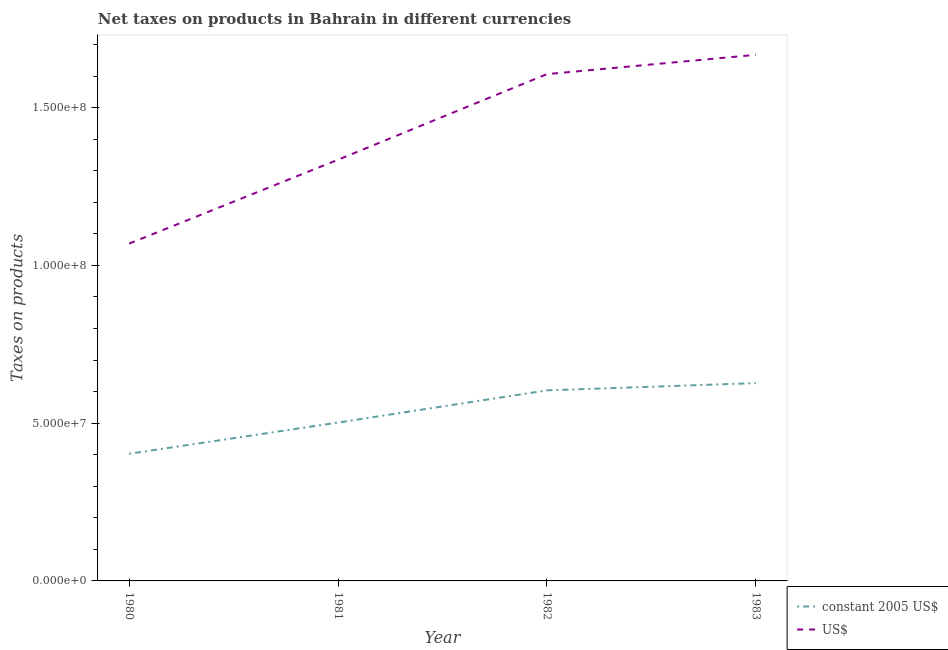How many different coloured lines are there?
Provide a succinct answer. 2. What is the net taxes in us$ in 1981?
Provide a short and direct response. 1.34e+08. Across all years, what is the maximum net taxes in us$?
Your answer should be compact. 1.67e+08. Across all years, what is the minimum net taxes in us$?
Offer a terse response. 1.07e+08. In which year was the net taxes in constant 2005 us$ maximum?
Keep it short and to the point. 1983. What is the total net taxes in us$ in the graph?
Make the answer very short. 5.68e+08. What is the difference between the net taxes in us$ in 1980 and that in 1981?
Keep it short and to the point. -2.66e+07. What is the difference between the net taxes in us$ in 1980 and the net taxes in constant 2005 us$ in 1982?
Offer a very short reply. 4.65e+07. What is the average net taxes in constant 2005 us$ per year?
Offer a terse response. 5.34e+07. In the year 1983, what is the difference between the net taxes in constant 2005 us$ and net taxes in us$?
Give a very brief answer. -1.04e+08. In how many years, is the net taxes in us$ greater than 140000000 units?
Your answer should be compact. 2. What is the ratio of the net taxes in constant 2005 us$ in 1980 to that in 1981?
Offer a terse response. 0.8. What is the difference between the highest and the second highest net taxes in constant 2005 us$?
Your response must be concise. 2.30e+06. What is the difference between the highest and the lowest net taxes in us$?
Keep it short and to the point. 5.98e+07. In how many years, is the net taxes in us$ greater than the average net taxes in us$ taken over all years?
Give a very brief answer. 2. Is the sum of the net taxes in us$ in 1981 and 1982 greater than the maximum net taxes in constant 2005 us$ across all years?
Provide a succinct answer. Yes. Does the net taxes in us$ monotonically increase over the years?
Offer a very short reply. Yes. Are the values on the major ticks of Y-axis written in scientific E-notation?
Your answer should be compact. Yes. Does the graph contain any zero values?
Offer a terse response. No. Does the graph contain grids?
Your answer should be compact. No. Where does the legend appear in the graph?
Your answer should be very brief. Bottom right. What is the title of the graph?
Your answer should be very brief. Net taxes on products in Bahrain in different currencies. Does "GDP" appear as one of the legend labels in the graph?
Provide a succinct answer. No. What is the label or title of the Y-axis?
Provide a short and direct response. Taxes on products. What is the Taxes on products of constant 2005 US$ in 1980?
Offer a terse response. 4.03e+07. What is the Taxes on products of US$ in 1980?
Make the answer very short. 1.07e+08. What is the Taxes on products of constant 2005 US$ in 1981?
Provide a succinct answer. 5.02e+07. What is the Taxes on products of US$ in 1981?
Give a very brief answer. 1.34e+08. What is the Taxes on products of constant 2005 US$ in 1982?
Your answer should be very brief. 6.04e+07. What is the Taxes on products in US$ in 1982?
Your answer should be very brief. 1.61e+08. What is the Taxes on products of constant 2005 US$ in 1983?
Provide a succinct answer. 6.27e+07. What is the Taxes on products of US$ in 1983?
Offer a very short reply. 1.67e+08. Across all years, what is the maximum Taxes on products in constant 2005 US$?
Your answer should be very brief. 6.27e+07. Across all years, what is the maximum Taxes on products of US$?
Offer a very short reply. 1.67e+08. Across all years, what is the minimum Taxes on products of constant 2005 US$?
Ensure brevity in your answer.  4.03e+07. Across all years, what is the minimum Taxes on products in US$?
Provide a succinct answer. 1.07e+08. What is the total Taxes on products in constant 2005 US$ in the graph?
Keep it short and to the point. 2.14e+08. What is the total Taxes on products in US$ in the graph?
Offer a terse response. 5.68e+08. What is the difference between the Taxes on products of constant 2005 US$ in 1980 and that in 1981?
Your response must be concise. -9.90e+06. What is the difference between the Taxes on products of US$ in 1980 and that in 1981?
Keep it short and to the point. -2.66e+07. What is the difference between the Taxes on products in constant 2005 US$ in 1980 and that in 1982?
Offer a terse response. -2.01e+07. What is the difference between the Taxes on products in US$ in 1980 and that in 1982?
Your answer should be compact. -5.37e+07. What is the difference between the Taxes on products of constant 2005 US$ in 1980 and that in 1983?
Offer a very short reply. -2.24e+07. What is the difference between the Taxes on products in US$ in 1980 and that in 1983?
Ensure brevity in your answer.  -5.98e+07. What is the difference between the Taxes on products of constant 2005 US$ in 1981 and that in 1982?
Your answer should be compact. -1.02e+07. What is the difference between the Taxes on products in US$ in 1981 and that in 1982?
Your answer should be compact. -2.71e+07. What is the difference between the Taxes on products of constant 2005 US$ in 1981 and that in 1983?
Your answer should be compact. -1.25e+07. What is the difference between the Taxes on products of US$ in 1981 and that in 1983?
Ensure brevity in your answer.  -3.32e+07. What is the difference between the Taxes on products in constant 2005 US$ in 1982 and that in 1983?
Your answer should be very brief. -2.30e+06. What is the difference between the Taxes on products in US$ in 1982 and that in 1983?
Keep it short and to the point. -6.12e+06. What is the difference between the Taxes on products of constant 2005 US$ in 1980 and the Taxes on products of US$ in 1981?
Provide a succinct answer. -9.32e+07. What is the difference between the Taxes on products in constant 2005 US$ in 1980 and the Taxes on products in US$ in 1982?
Provide a short and direct response. -1.20e+08. What is the difference between the Taxes on products of constant 2005 US$ in 1980 and the Taxes on products of US$ in 1983?
Your answer should be very brief. -1.26e+08. What is the difference between the Taxes on products of constant 2005 US$ in 1981 and the Taxes on products of US$ in 1982?
Provide a succinct answer. -1.10e+08. What is the difference between the Taxes on products of constant 2005 US$ in 1981 and the Taxes on products of US$ in 1983?
Make the answer very short. -1.17e+08. What is the difference between the Taxes on products of constant 2005 US$ in 1982 and the Taxes on products of US$ in 1983?
Ensure brevity in your answer.  -1.06e+08. What is the average Taxes on products in constant 2005 US$ per year?
Your answer should be compact. 5.34e+07. What is the average Taxes on products of US$ per year?
Offer a terse response. 1.42e+08. In the year 1980, what is the difference between the Taxes on products of constant 2005 US$ and Taxes on products of US$?
Your answer should be compact. -6.66e+07. In the year 1981, what is the difference between the Taxes on products in constant 2005 US$ and Taxes on products in US$?
Give a very brief answer. -8.33e+07. In the year 1982, what is the difference between the Taxes on products of constant 2005 US$ and Taxes on products of US$?
Offer a very short reply. -1.00e+08. In the year 1983, what is the difference between the Taxes on products of constant 2005 US$ and Taxes on products of US$?
Offer a very short reply. -1.04e+08. What is the ratio of the Taxes on products of constant 2005 US$ in 1980 to that in 1981?
Keep it short and to the point. 0.8. What is the ratio of the Taxes on products in US$ in 1980 to that in 1981?
Offer a terse response. 0.8. What is the ratio of the Taxes on products in constant 2005 US$ in 1980 to that in 1982?
Your answer should be compact. 0.67. What is the ratio of the Taxes on products in US$ in 1980 to that in 1982?
Keep it short and to the point. 0.67. What is the ratio of the Taxes on products of constant 2005 US$ in 1980 to that in 1983?
Offer a very short reply. 0.64. What is the ratio of the Taxes on products in US$ in 1980 to that in 1983?
Keep it short and to the point. 0.64. What is the ratio of the Taxes on products of constant 2005 US$ in 1981 to that in 1982?
Offer a terse response. 0.83. What is the ratio of the Taxes on products of US$ in 1981 to that in 1982?
Offer a terse response. 0.83. What is the ratio of the Taxes on products of constant 2005 US$ in 1981 to that in 1983?
Your answer should be very brief. 0.8. What is the ratio of the Taxes on products in US$ in 1981 to that in 1983?
Give a very brief answer. 0.8. What is the ratio of the Taxes on products in constant 2005 US$ in 1982 to that in 1983?
Your answer should be very brief. 0.96. What is the ratio of the Taxes on products in US$ in 1982 to that in 1983?
Provide a short and direct response. 0.96. What is the difference between the highest and the second highest Taxes on products in constant 2005 US$?
Offer a very short reply. 2.30e+06. What is the difference between the highest and the second highest Taxes on products in US$?
Your answer should be compact. 6.12e+06. What is the difference between the highest and the lowest Taxes on products in constant 2005 US$?
Ensure brevity in your answer.  2.24e+07. What is the difference between the highest and the lowest Taxes on products in US$?
Ensure brevity in your answer.  5.98e+07. 